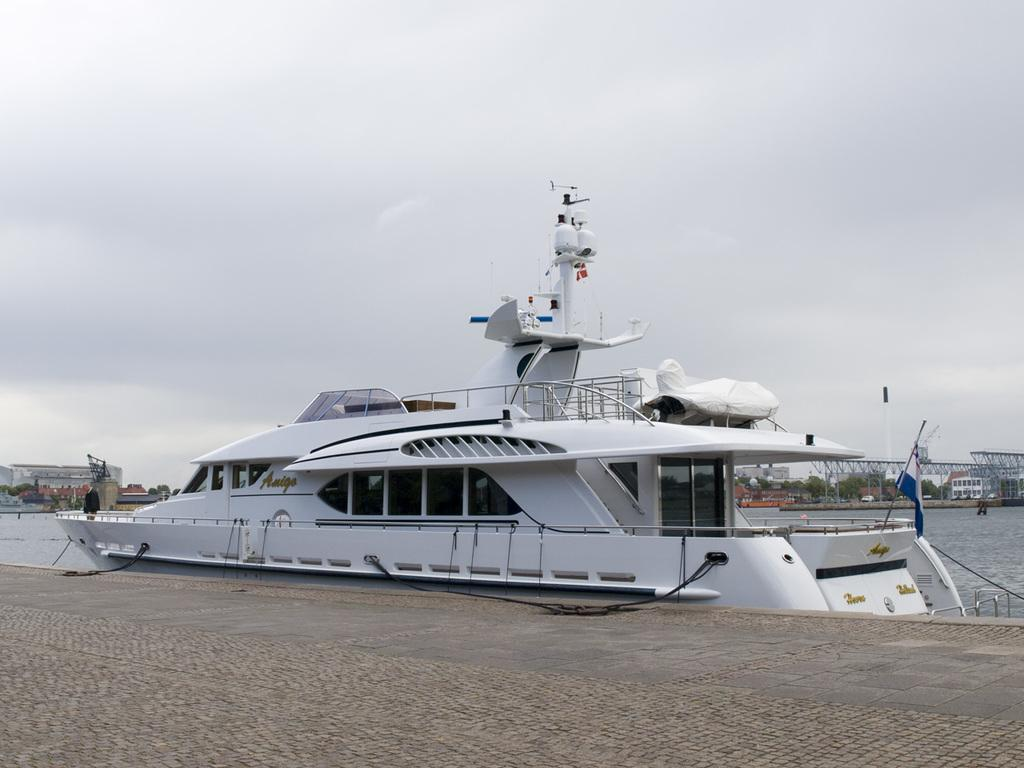What is the main subject in the center of the image? There is a ship in the water in the center of the image. What is located in front of the ship? There is a pavement in front of the ship. What can be seen in the background of the image? There are buildings, trees, and the sky visible in the background of the image. How many women are playing music on the ship in the image? There are no women or music present in the image; it features a ship in the water with a pavement in front and buildings, trees, and the sky in the background. 